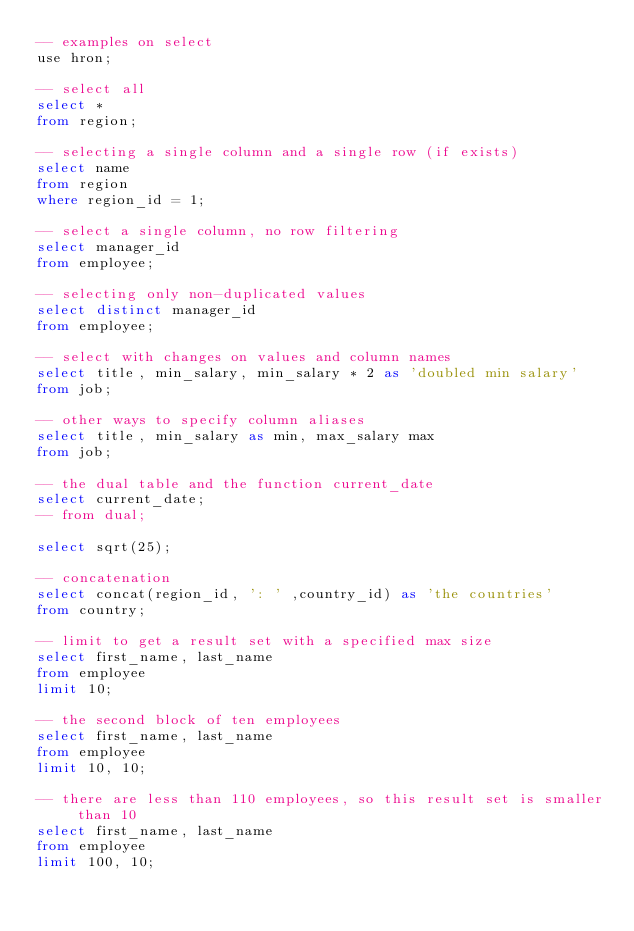Convert code to text. <code><loc_0><loc_0><loc_500><loc_500><_SQL_>-- examples on select
use hron;

-- select all
select *
from region;

-- selecting a single column and a single row (if exists)
select name
from region
where region_id = 1;

-- select a single column, no row filtering
select manager_id
from employee;

-- selecting only non-duplicated values
select distinct manager_id
from employee;

-- select with changes on values and column names
select title, min_salary, min_salary * 2 as 'doubled min salary'
from job;

-- other ways to specify column aliases
select title, min_salary as min, max_salary max
from job;

-- the dual table and the function current_date
select current_date;
-- from dual;

select sqrt(25);

-- concatenation
select concat(region_id, ': ' ,country_id) as 'the countries'
from country;

-- limit to get a result set with a specified max size
select first_name, last_name
from employee
limit 10;

-- the second block of ten employees
select first_name, last_name
from employee
limit 10, 10;

-- there are less than 110 employees, so this result set is smaller than 10
select first_name, last_name
from employee
limit 100, 10;
</code> 